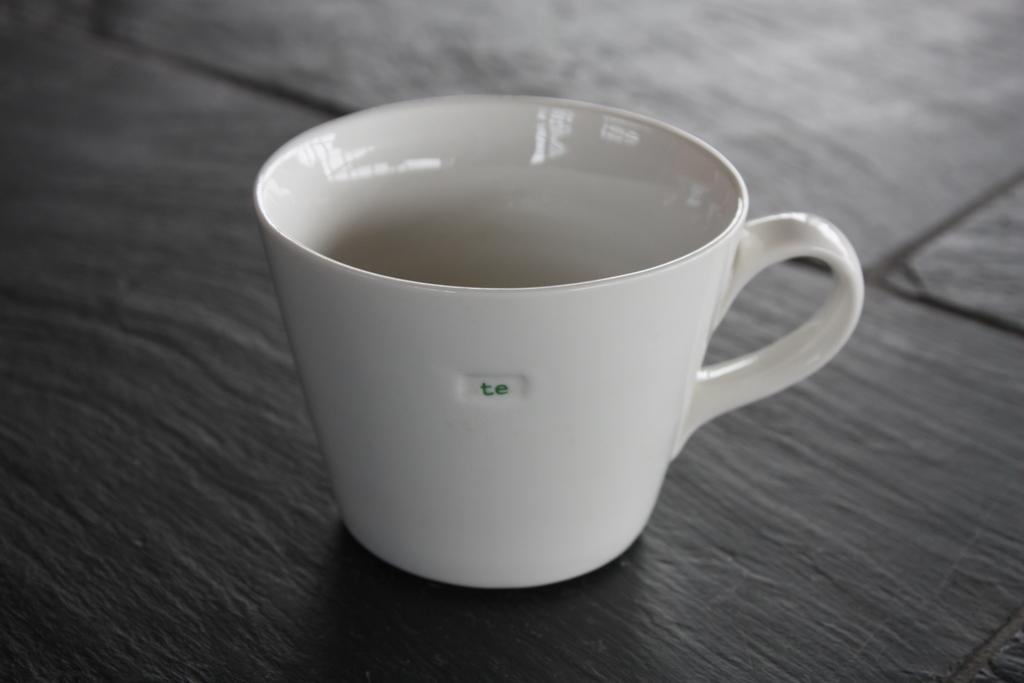Provide a one-sentence caption for the provided image. An empty white tea cup with the initials te embossed on it's side sits on a tiled table. 